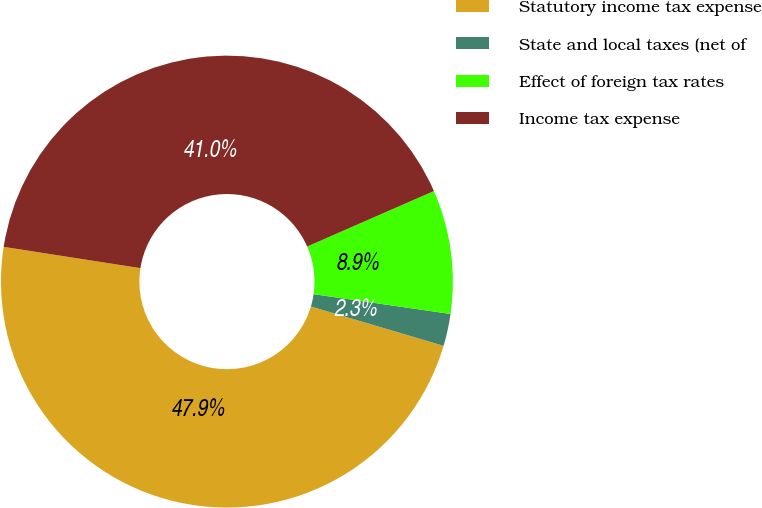<chart> <loc_0><loc_0><loc_500><loc_500><pie_chart><fcel>Statutory income tax expense<fcel>State and local taxes (net of<fcel>Effect of foreign tax rates<fcel>Income tax expense<nl><fcel>47.87%<fcel>2.3%<fcel>8.85%<fcel>40.98%<nl></chart> 